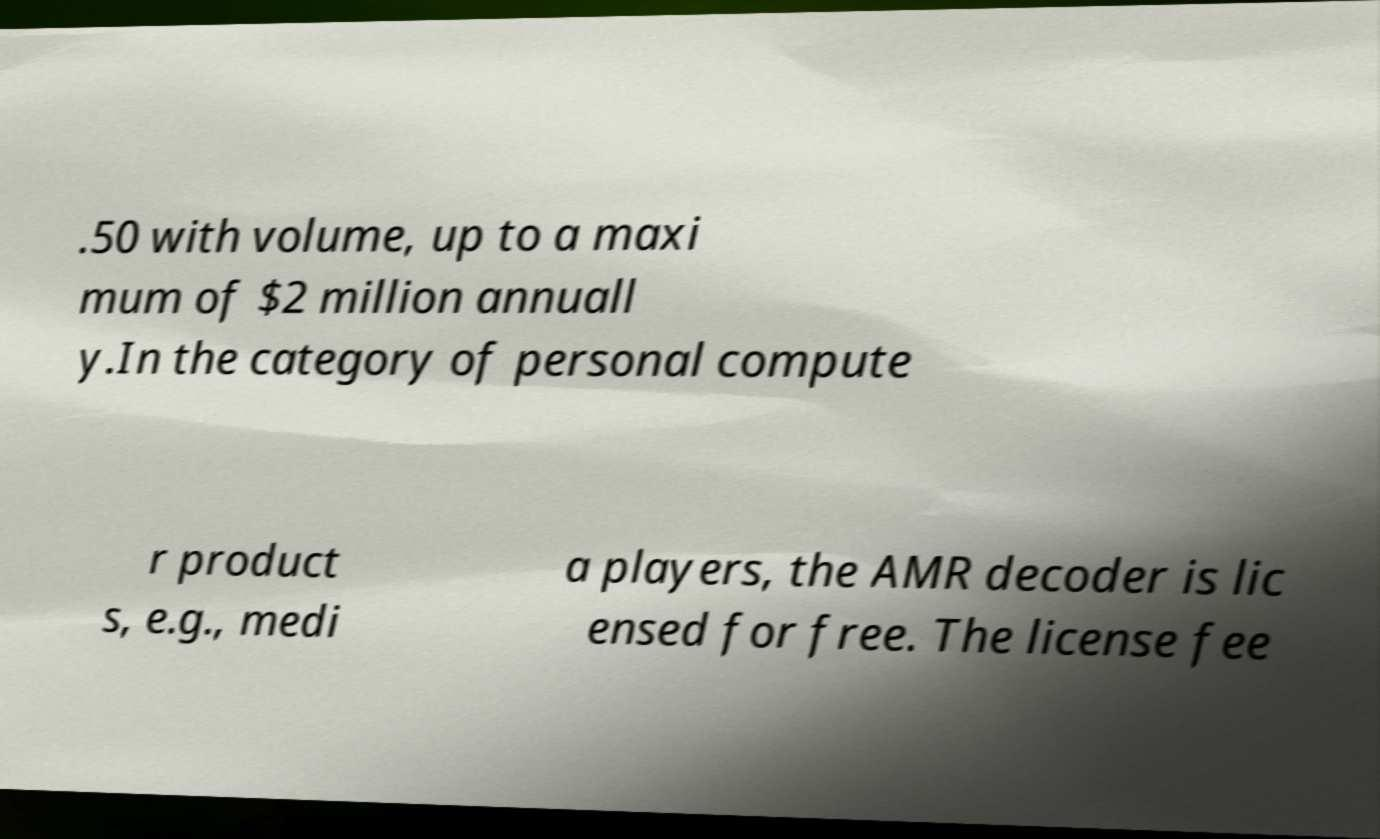What messages or text are displayed in this image? I need them in a readable, typed format. .50 with volume, up to a maxi mum of $2 million annuall y.In the category of personal compute r product s, e.g., medi a players, the AMR decoder is lic ensed for free. The license fee 